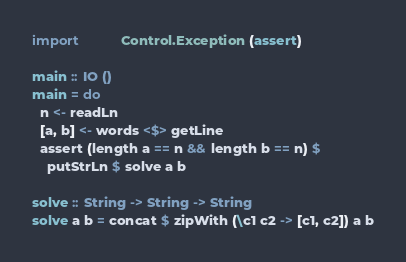<code> <loc_0><loc_0><loc_500><loc_500><_Haskell_>import           Control.Exception (assert)

main :: IO ()
main = do
  n <- readLn
  [a, b] <- words <$> getLine
  assert (length a == n && length b == n) $
    putStrLn $ solve a b

solve :: String -> String -> String
solve a b = concat $ zipWith (\c1 c2 -> [c1, c2]) a b
</code> 